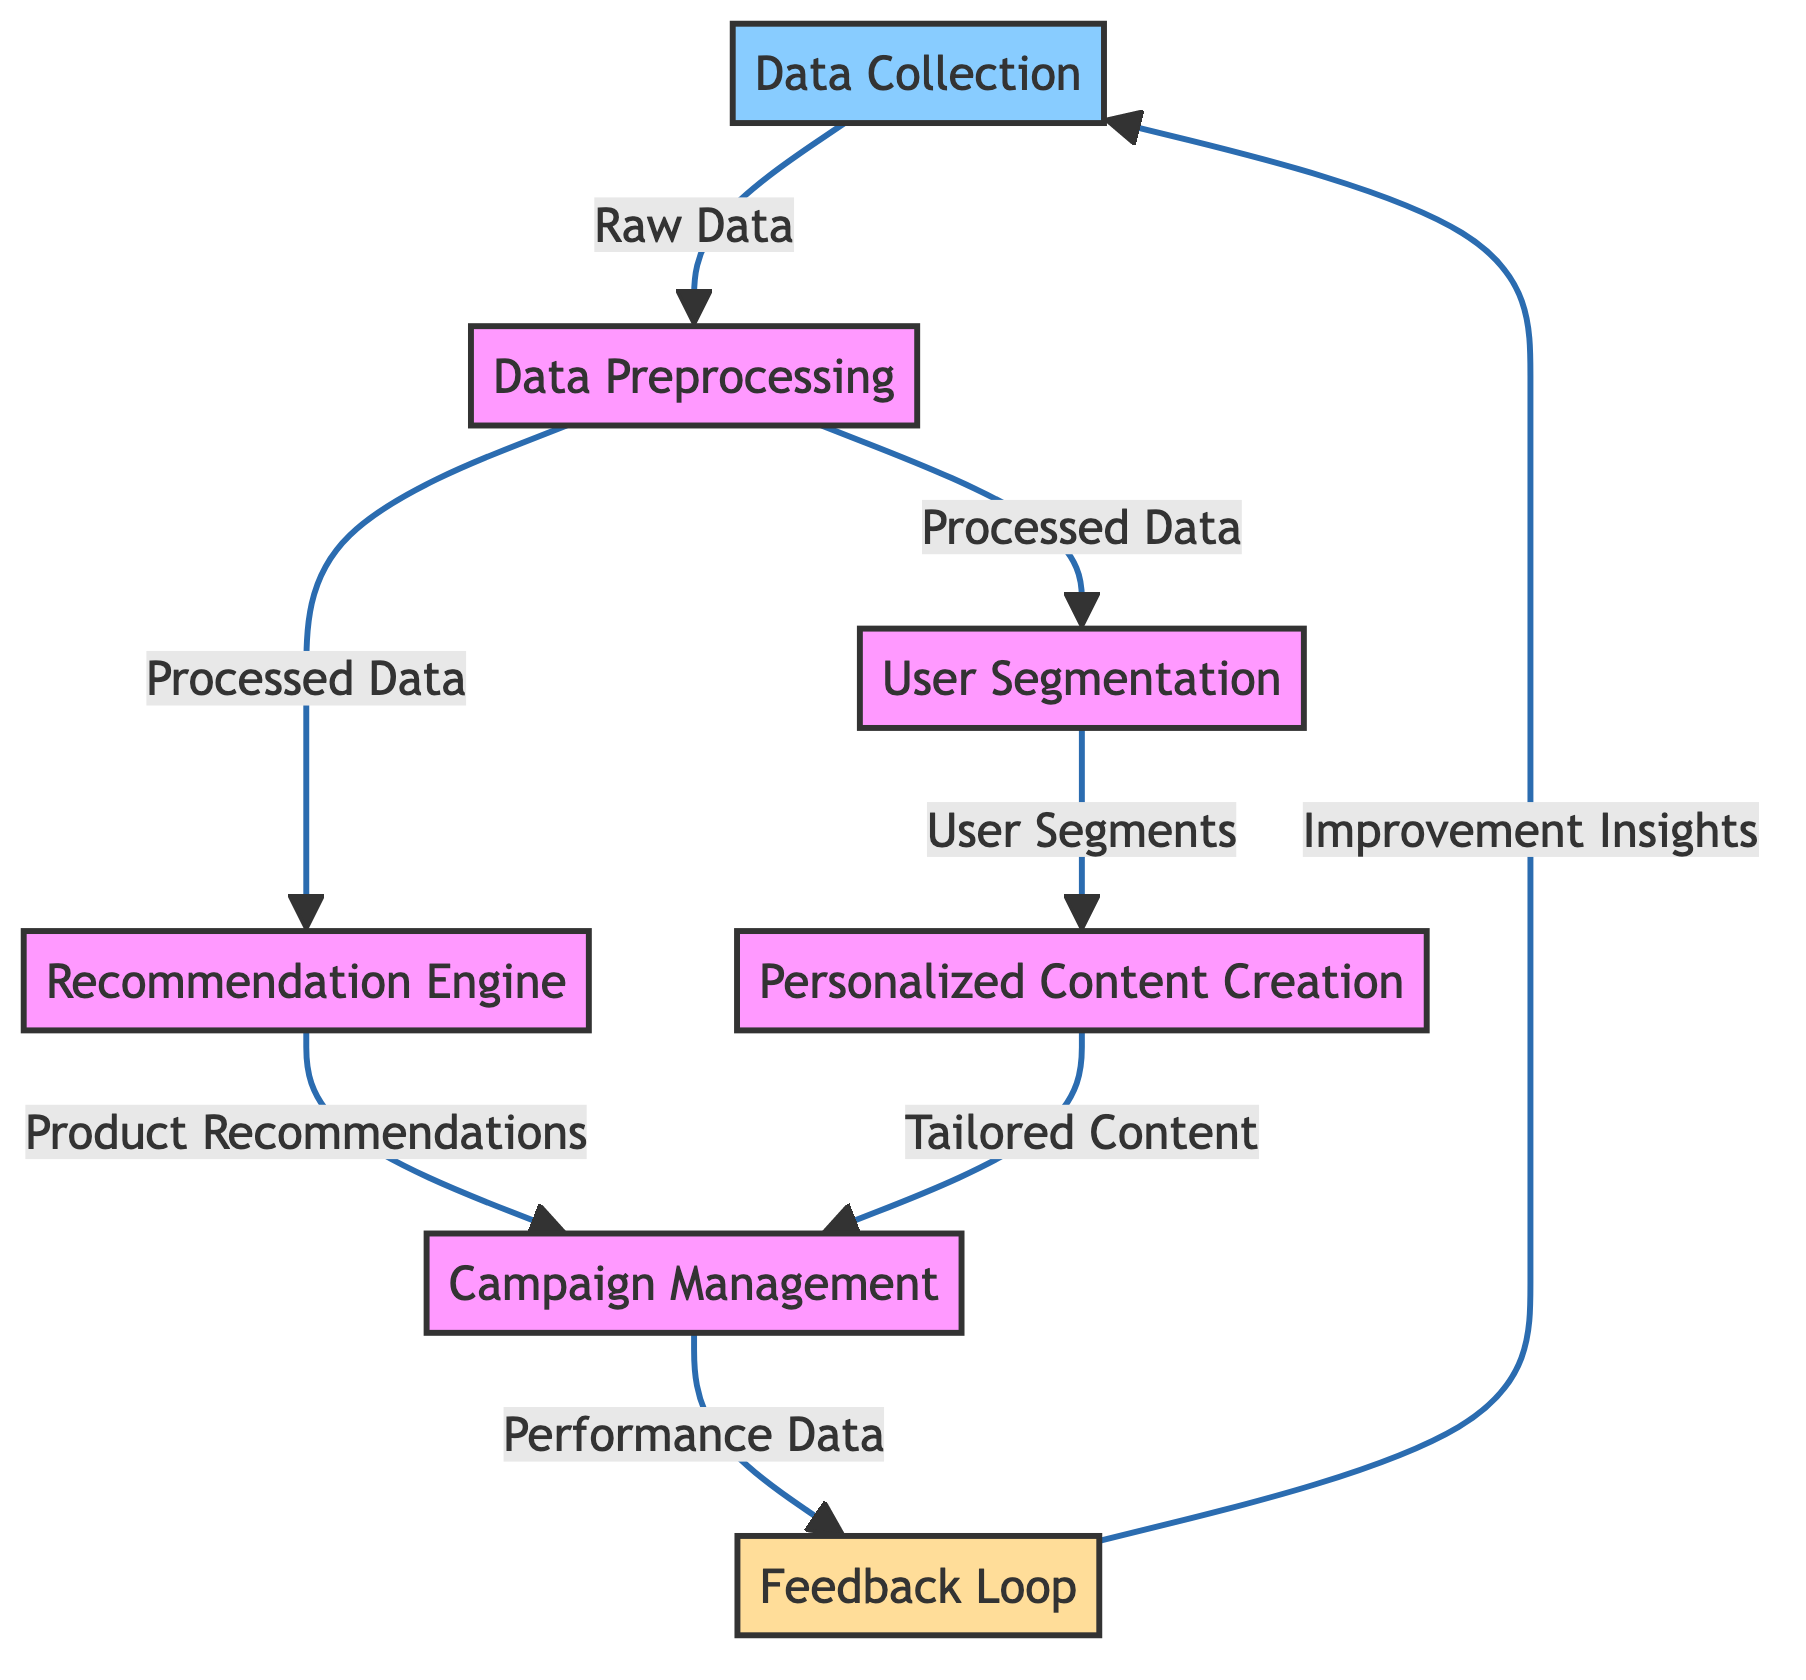What is the first step in the diagram? The first step in the diagram is "Data Collection." This can be determined by looking at the flowchart, where the initial process without any inputs is labeled as "Data Collection."
Answer: Data Collection How many nodes are present in the diagram? By counting all the distinct processes represented in the diagram, we find there are seven nodes: Data Collection, Data Preprocessing, User Segmentation, Recommendation Engine, Personalized Content Creation, Campaign Management, and Feedback Loop.
Answer: 7 What is the output of the Data Preprocessing node? The Data Preprocessing node outputs to two other nodes: User Segmentation and Recommendation Engine. This indicates that the processed data will be used to facilitate both segmenting users and making product recommendations.
Answer: User Segmentation, Recommendation Engine Which node is responsible for creating tailored marketing content? The node responsible for creating tailored marketing content is "Personalized Content Creation." This is shown in the diagram where User Segmentation feeds into the Personalized Content Creation step.
Answer: Personalized Content Creation Which two nodes feed into the Campaign Management node? The Campaign Management node receives input from two nodes: "Recommendation Engine" and "Personalized Content Creation." This can be understood from the arrows leading into the Campaign Management node that originate from these two processes.
Answer: Recommendation Engine, Personalized Content Creation What type of algorithm does the User Segmentation node suggest using? The User Segmentation node suggests using clustering algorithms, specifically mentioning K-means or hierarchical clustering. This information is included in the description of the node within the diagram.
Answer: Clustering algorithms What feedback is collected in the Feedback Loop? The Feedback Loop collects feedback and performance data from the marketing campaigns to further tune and improve the algorithms. This is articulated in the node's description in the diagram.
Answer: Feedback and performance data What is the final output that returns to the Data Collection step? The final output that returns to the Data Collection step is "Improvement Insights." This can be traced along the arrows to see that the Feedback Loop directly outputs these insights back to the Data Collection node.
Answer: Improvement Insights Which node is the last processing step before Campaign Management? The last processing step before Campaign Management is either "Recommendation Engine" or "Personalized Content Creation," as both feed into Campaign Management before any further steps are taken.
Answer: Recommendation Engine, Personalized Content Creation 